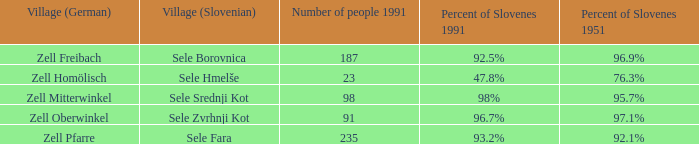9% of the population were slovenes in 1951? Zell Freibach. 